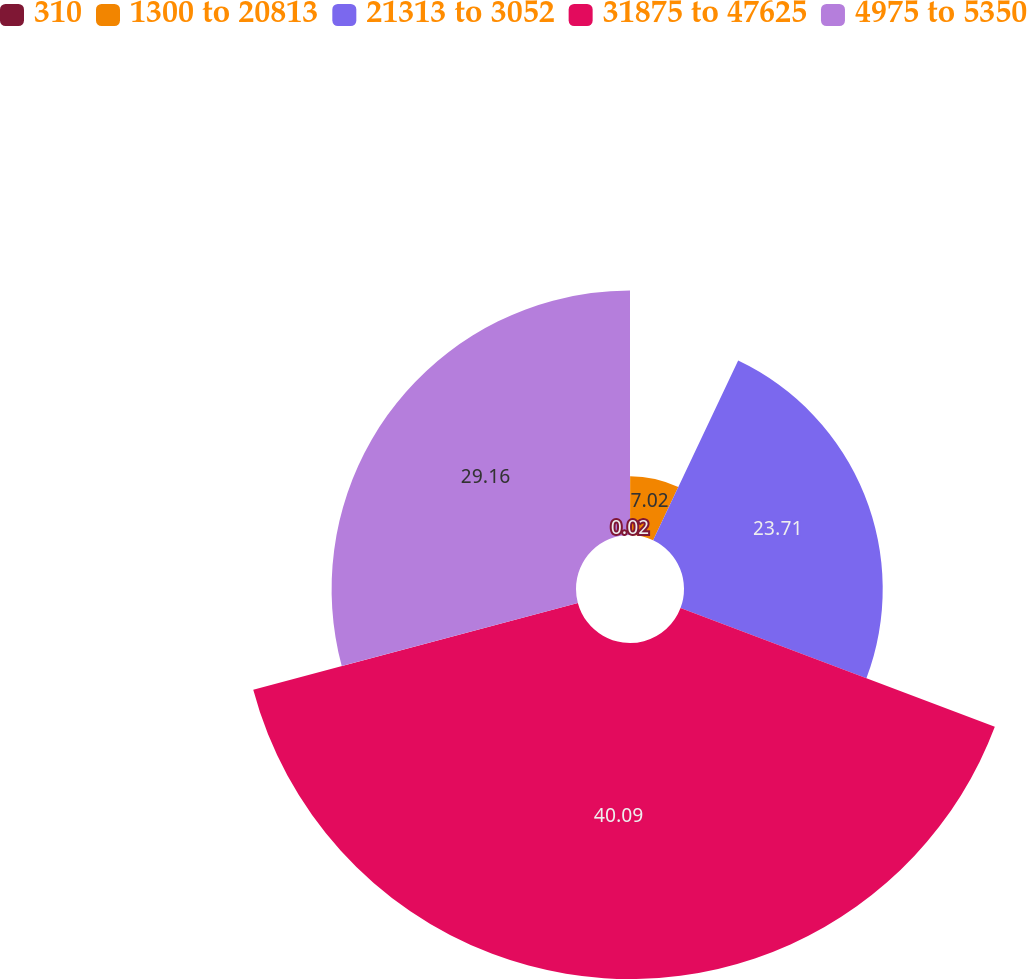Convert chart. <chart><loc_0><loc_0><loc_500><loc_500><pie_chart><fcel>310<fcel>1300 to 20813<fcel>21313 to 3052<fcel>31875 to 47625<fcel>4975 to 5350<nl><fcel>0.02%<fcel>7.02%<fcel>23.71%<fcel>40.09%<fcel>29.16%<nl></chart> 